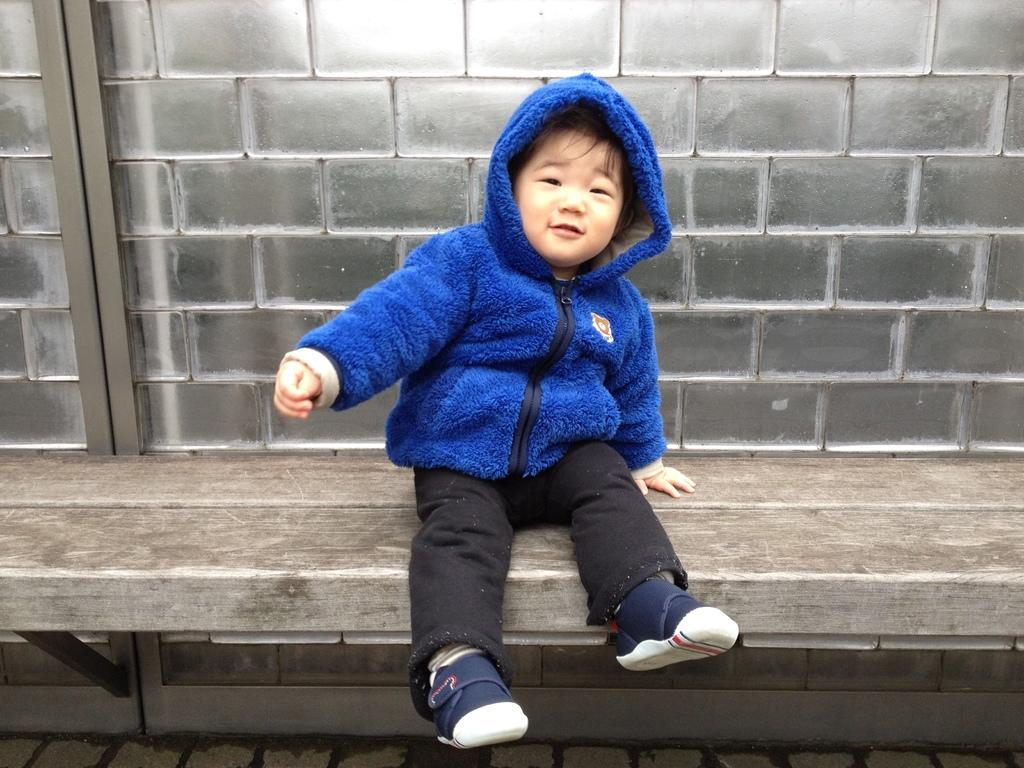What is the main subject of the image? There is a child in the image. What is the child wearing? The child is wearing a sweater. Where is the child sitting? The child is sitting on a bench. What is the child's facial expression? The child is smiling. What color is the child's toe in the image? There is no specific mention of the child's toe in the image, so we cannot determine its color. 